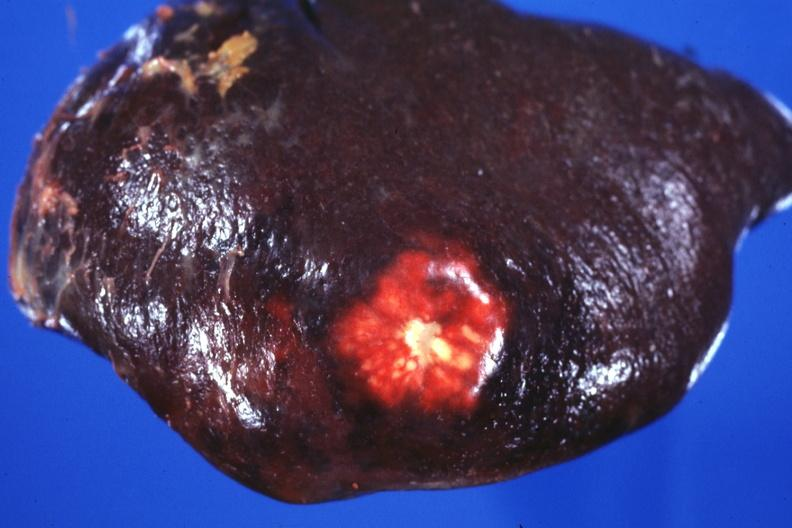what does this image show?
Answer the question using a single word or phrase. External view of spleen with obvious metastatic nodule beneath capsule 